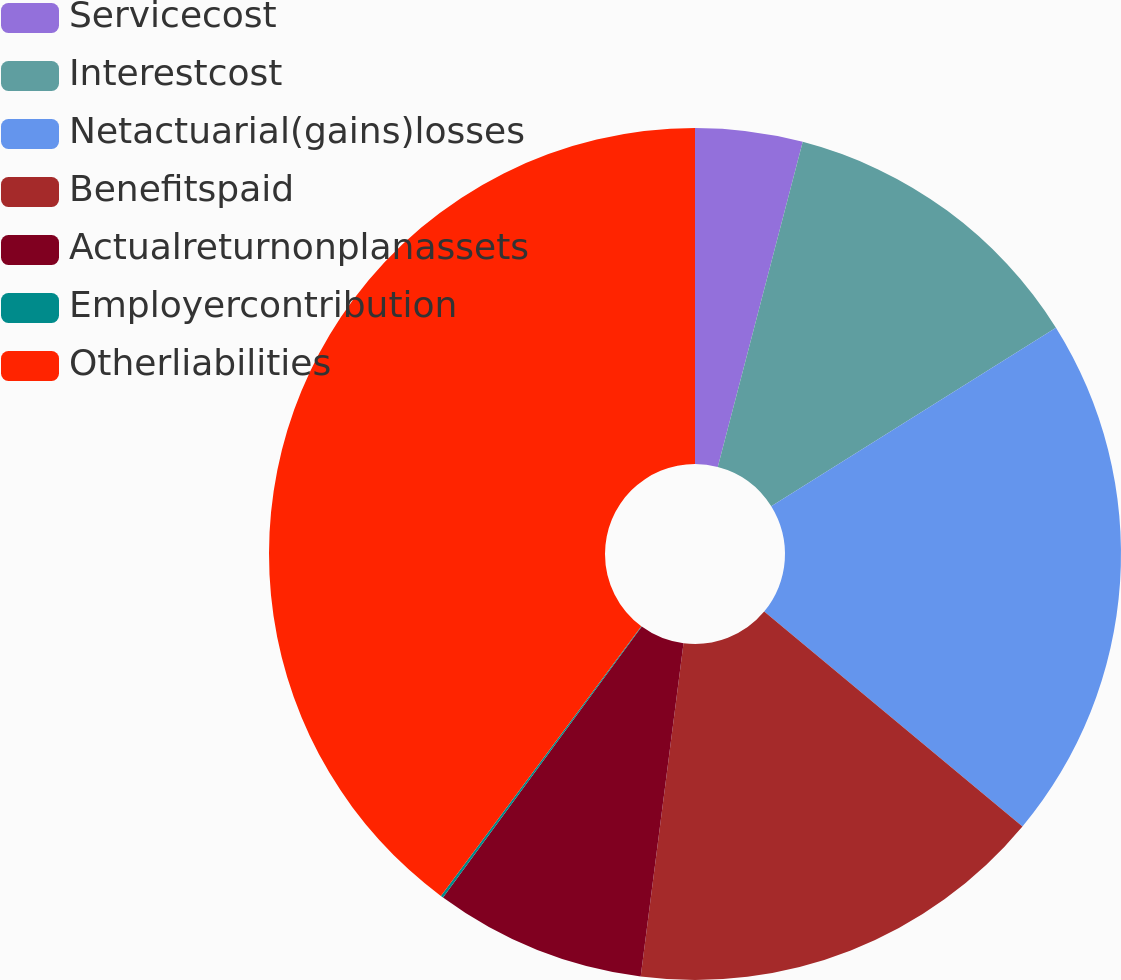<chart> <loc_0><loc_0><loc_500><loc_500><pie_chart><fcel>Servicecost<fcel>Interestcost<fcel>Netactuarial(gains)losses<fcel>Benefitspaid<fcel>Actualreturnonplanassets<fcel>Employercontribution<fcel>Otherliabilities<nl><fcel>4.07%<fcel>12.02%<fcel>19.96%<fcel>15.99%<fcel>8.04%<fcel>0.1%<fcel>39.83%<nl></chart> 